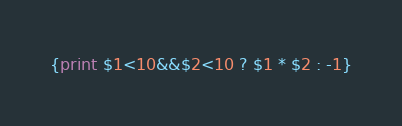<code> <loc_0><loc_0><loc_500><loc_500><_Awk_>{print $1<10&&$2<10 ? $1 * $2 : -1}</code> 